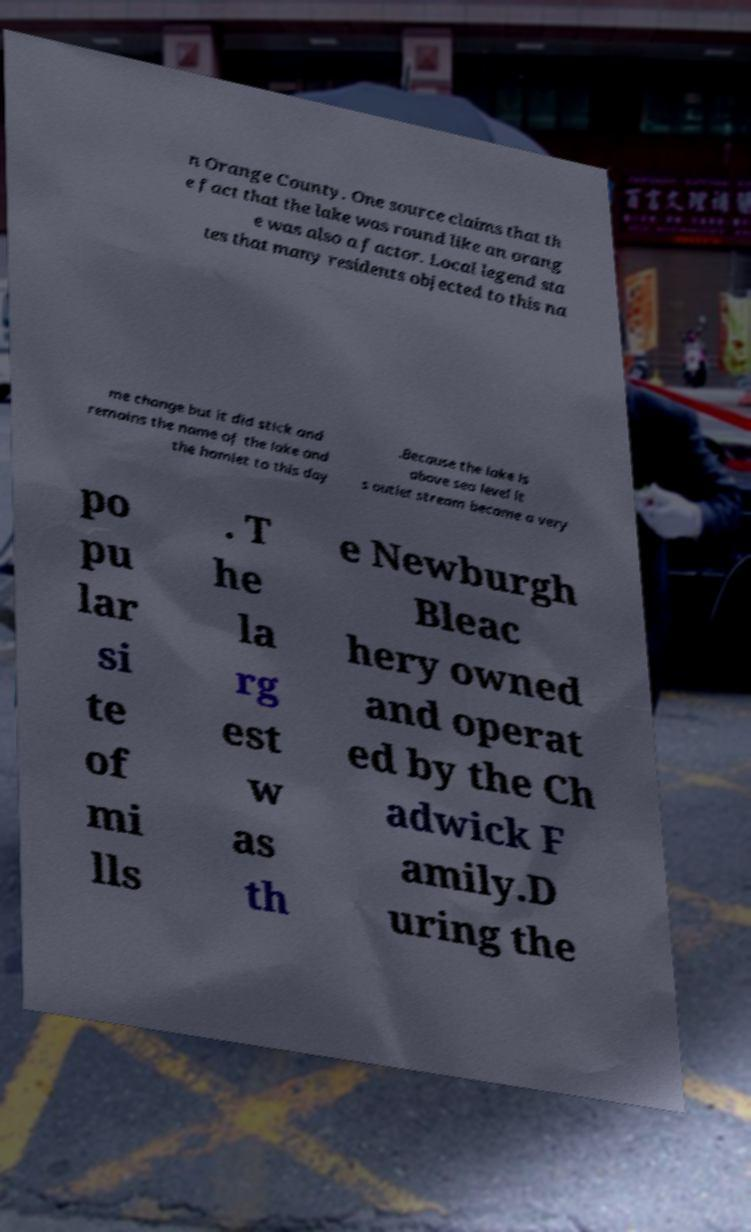There's text embedded in this image that I need extracted. Can you transcribe it verbatim? n Orange County. One source claims that th e fact that the lake was round like an orang e was also a factor. Local legend sta tes that many residents objected to this na me change but it did stick and remains the name of the lake and the hamlet to this day .Because the lake is above sea level it s outlet stream became a very po pu lar si te of mi lls . T he la rg est w as th e Newburgh Bleac hery owned and operat ed by the Ch adwick F amily.D uring the 